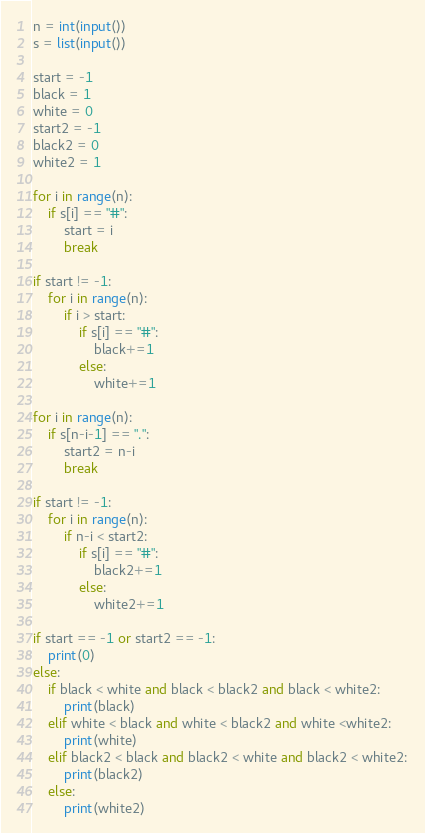<code> <loc_0><loc_0><loc_500><loc_500><_Python_>n = int(input())
s = list(input())

start = -1
black = 1
white = 0
start2 = -1
black2 = 0
white2 = 1

for i in range(n):
    if s[i] == "#":
        start = i
        break

if start != -1:
    for i in range(n):
        if i > start:
            if s[i] == "#":
                black+=1
            else:
                white+=1

for i in range(n):
    if s[n-i-1] == ".":
        start2 = n-i
        break

if start != -1:
    for i in range(n):
        if n-i < start2:
            if s[i] == "#":
                black2+=1
            else:
                white2+=1

if start == -1 or start2 == -1:
    print(0)
else:
    if black < white and black < black2 and black < white2:
        print(black)
    elif white < black and white < black2 and white <white2:
        print(white)
    elif black2 < black and black2 < white and black2 < white2:
        print(black2)
    else:
        print(white2)</code> 